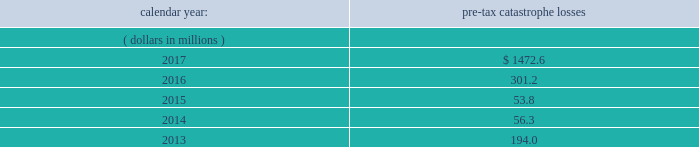Item 1a .
Risk factors in addition to the other information provided in this report , the following risk factors should be considered when evaluating an investment in our securities .
If the circumstances contemplated by the individual risk factors materialize , our business , financial condition and results of operations could be materially and adversely affected and the trading price of our common shares could decline significantly .
Risks relating to our business fluctuations in the financial markets could result in investment losses .
Prolonged and severe disruptions in the overall public debt and equity markets , such as occurred during 2008 , could result in significant realized and unrealized losses in our investment portfolio .
Although financial markets have significantly improved since 2008 , they could deteriorate in the future .
There could also be disruption in individual market sectors , such as occurred in the energy sector in recent years .
Such declines in the financial markets could result in significant realized and unrealized losses on investments and could have a material adverse impact on our results of operations , equity , business and insurer financial strength and debt ratings .
Our results could be adversely affected by catastrophic events .
We are exposed to unpredictable catastrophic events , including weather-related and other natural catastrophes , as well as acts of terrorism .
Any material reduction in our operating results caused by the occurrence of one or more catastrophes could inhibit our ability to pay dividends or to meet our interest and principal payment obligations .
By way of illustration , during the past five calendar years , pre-tax catastrophe losses , net of reinsurance , were as follows: .
Our losses from future catastrophic events could exceed our projections .
We use projections of possible losses from future catastrophic events of varying types and magnitudes as a strategic underwriting tool .
We use these loss projections to estimate our potential catastrophe losses in certain geographic areas and decide on the placement of retrocessional coverage or other actions to limit the extent of potential losses in a given geographic area .
These loss projections are approximations , reliant on a mix of quantitative and qualitative processes , and actual losses may exceed the projections by a material amount , resulting in a material adverse effect on our financial condition and results of operations. .
What are the total pre-tax catastrophe losses for the company in the last three years?\\n? 
Computations: ((1472.6 + 301.2) + 53.8)
Answer: 1827.6. 